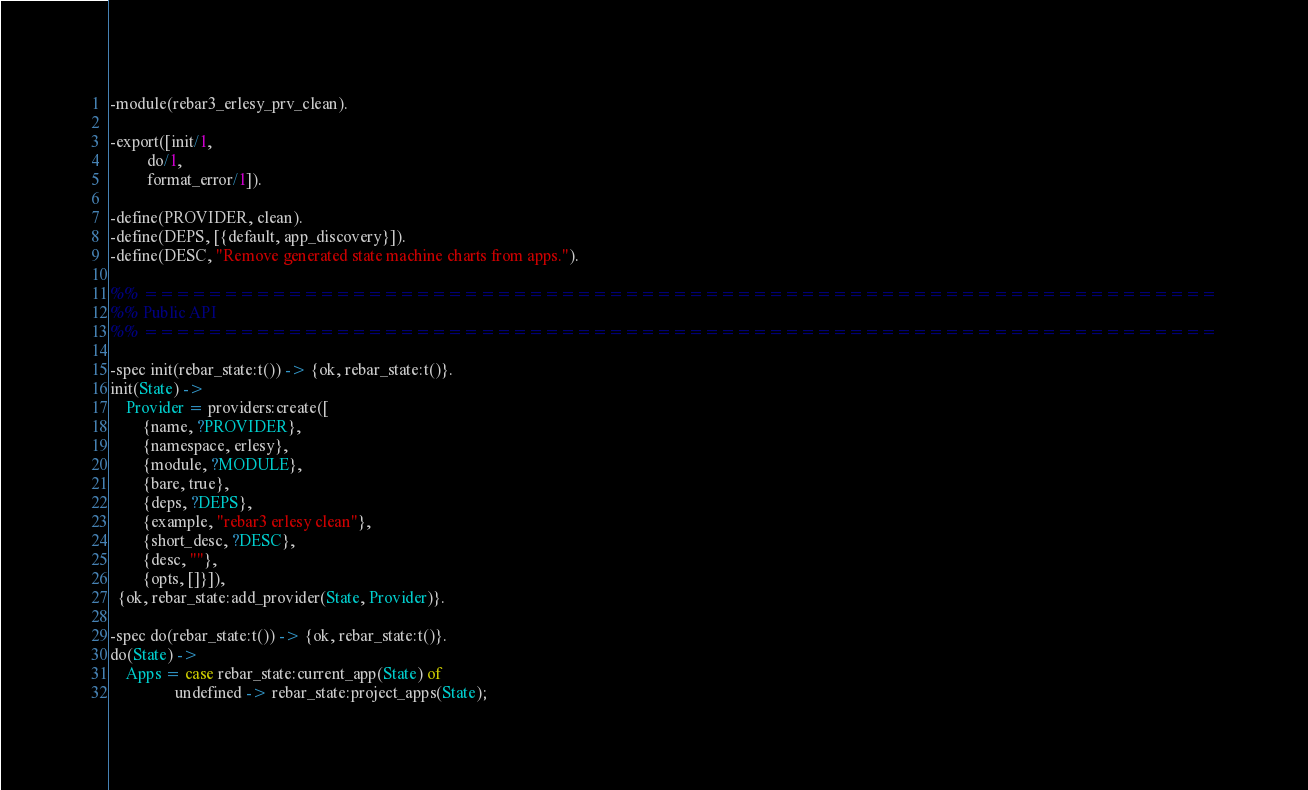Convert code to text. <code><loc_0><loc_0><loc_500><loc_500><_Erlang_>-module(rebar3_erlesy_prv_clean).

-export([init/1,
         do/1,
         format_error/1]).

-define(PROVIDER, clean).
-define(DEPS, [{default, app_discovery}]).
-define(DESC, "Remove generated state machine charts from apps.").

%% ===================================================================
%% Public API
%% ===================================================================

-spec init(rebar_state:t()) -> {ok, rebar_state:t()}.
init(State) ->
    Provider = providers:create([
        {name, ?PROVIDER},
        {namespace, erlesy},
        {module, ?MODULE},
        {bare, true},
        {deps, ?DEPS},
        {example, "rebar3 erlesy clean"},
        {short_desc, ?DESC},
        {desc, ""},
        {opts, []}]),
  {ok, rebar_state:add_provider(State, Provider)}.

-spec do(rebar_state:t()) -> {ok, rebar_state:t()}.
do(State) ->
    Apps = case rebar_state:current_app(State) of
                undefined -> rebar_state:project_apps(State);</code> 